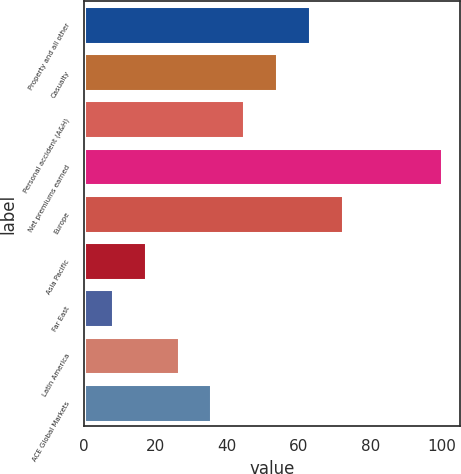Convert chart. <chart><loc_0><loc_0><loc_500><loc_500><bar_chart><fcel>Property and all other<fcel>Casualty<fcel>Personal accident (A&H)<fcel>Net premiums earned<fcel>Europe<fcel>Asia Pacific<fcel>Far East<fcel>Latin America<fcel>ACE Global Markets<nl><fcel>63.2<fcel>54<fcel>44.8<fcel>100<fcel>72.4<fcel>17.2<fcel>8<fcel>26.4<fcel>35.6<nl></chart> 